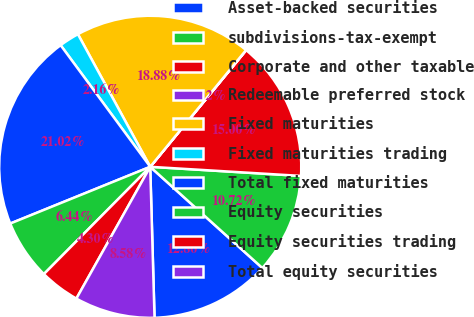<chart> <loc_0><loc_0><loc_500><loc_500><pie_chart><fcel>Asset-backed securities<fcel>subdivisions-tax-exempt<fcel>Corporate and other taxable<fcel>Redeemable preferred stock<fcel>Fixed maturities<fcel>Fixed maturities trading<fcel>Total fixed maturities<fcel>Equity securities<fcel>Equity securities trading<fcel>Total equity securities<nl><fcel>12.86%<fcel>10.72%<fcel>15.0%<fcel>0.02%<fcel>18.88%<fcel>2.16%<fcel>21.02%<fcel>6.44%<fcel>4.3%<fcel>8.58%<nl></chart> 